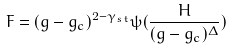<formula> <loc_0><loc_0><loc_500><loc_500>F = ( g - g _ { c } ) ^ { 2 - \gamma _ { s t } } \psi ( { \frac { H } { ( g - g _ { c } ) ^ { \Delta } } } )</formula> 